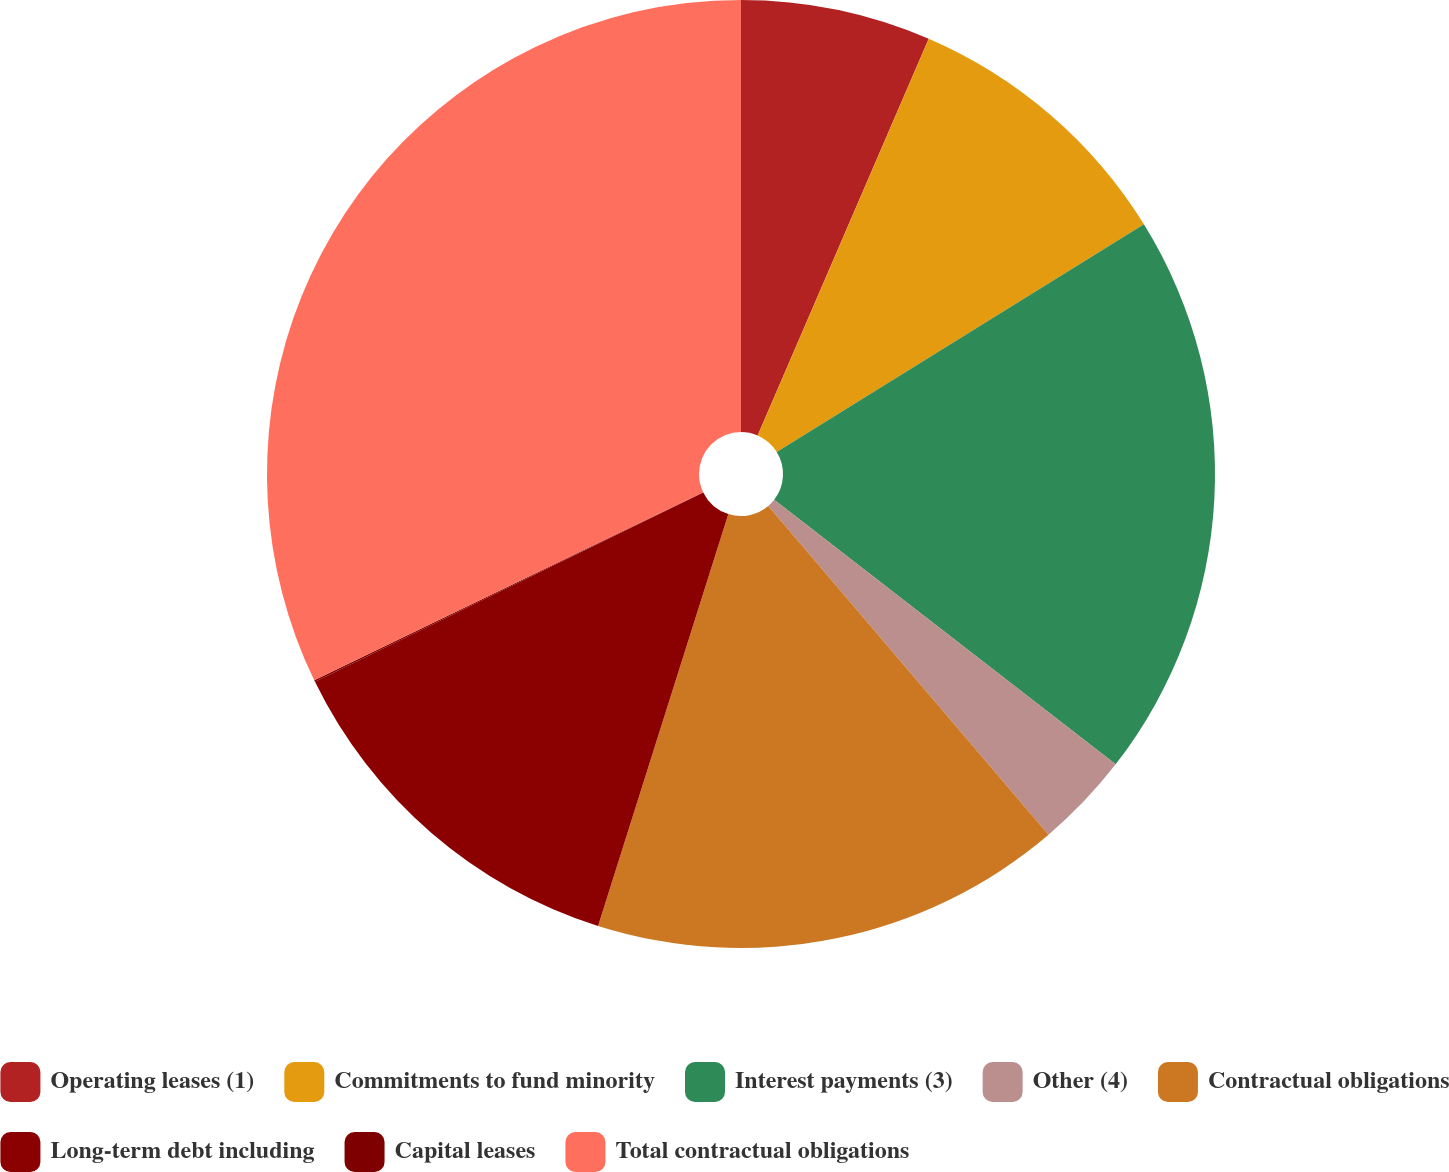Convert chart. <chart><loc_0><loc_0><loc_500><loc_500><pie_chart><fcel>Operating leases (1)<fcel>Commitments to fund minority<fcel>Interest payments (3)<fcel>Other (4)<fcel>Contractual obligations<fcel>Long-term debt including<fcel>Capital leases<fcel>Total contractual obligations<nl><fcel>6.48%<fcel>9.69%<fcel>19.32%<fcel>3.27%<fcel>16.11%<fcel>12.9%<fcel>0.06%<fcel>32.16%<nl></chart> 